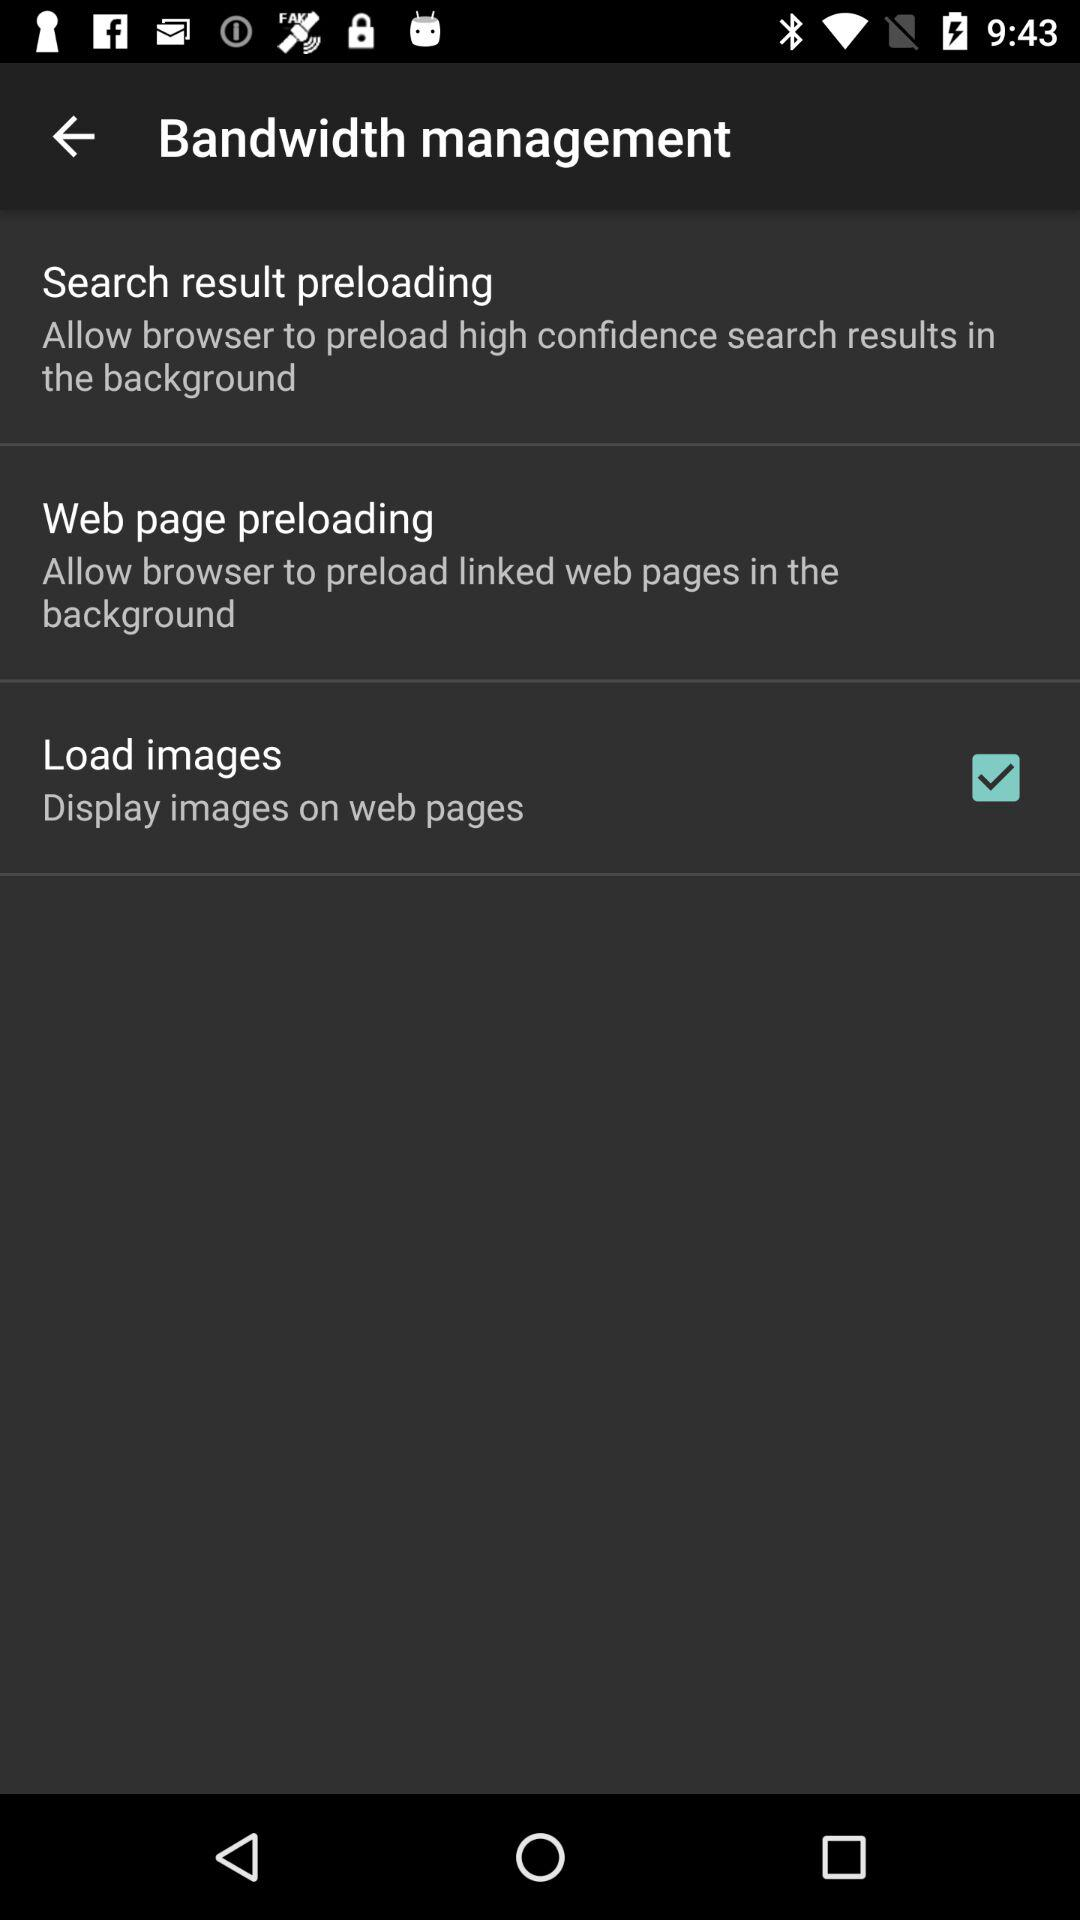How many items allow the browser to preload content in the background?
Answer the question using a single word or phrase. 3 